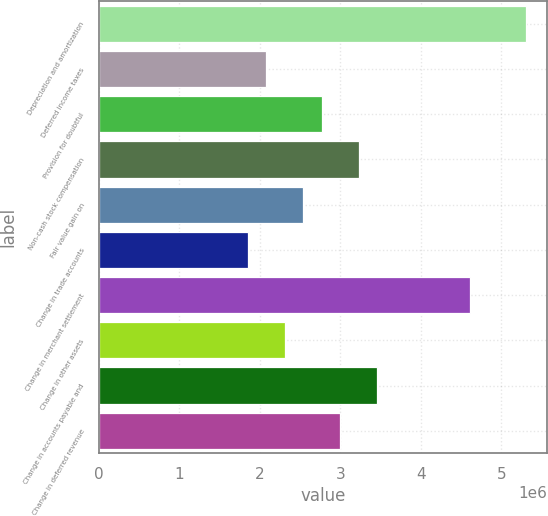<chart> <loc_0><loc_0><loc_500><loc_500><bar_chart><fcel>Depreciation and amortization<fcel>Deferred income taxes<fcel>Provision for doubtful<fcel>Non-cash stock compensation<fcel>Fair value gain on<fcel>Change in trade accounts<fcel>Change in merchant settlement<fcel>Change in other assets<fcel>Change in accounts payable and<fcel>Change in deferred revenue<nl><fcel>5.30195e+06<fcel>2.07877e+06<fcel>2.76945e+06<fcel>3.22991e+06<fcel>2.53923e+06<fcel>1.84855e+06<fcel>4.61127e+06<fcel>2.309e+06<fcel>3.46014e+06<fcel>2.99968e+06<nl></chart> 